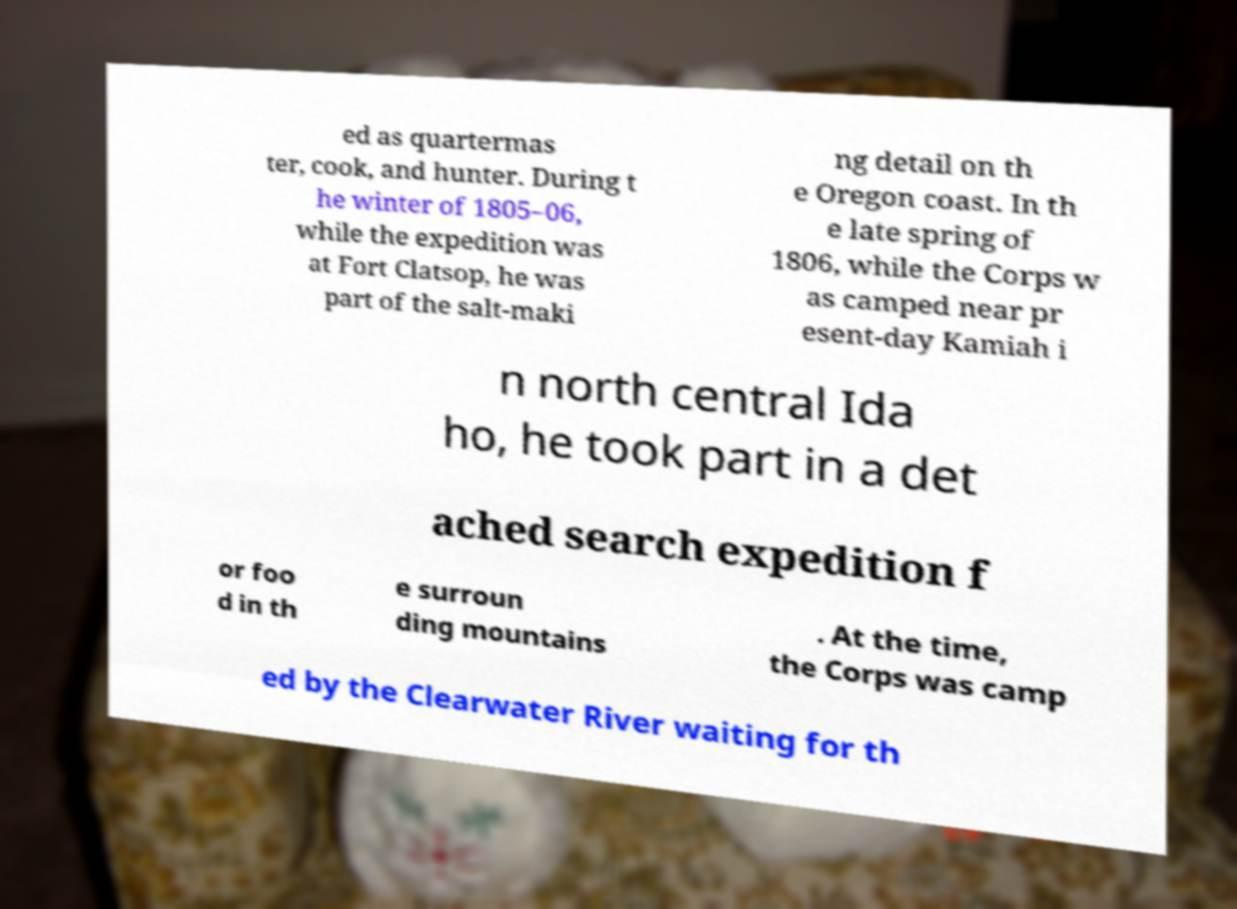Please identify and transcribe the text found in this image. ed as quartermas ter, cook, and hunter. During t he winter of 1805–06, while the expedition was at Fort Clatsop, he was part of the salt-maki ng detail on th e Oregon coast. In th e late spring of 1806, while the Corps w as camped near pr esent-day Kamiah i n north central Ida ho, he took part in a det ached search expedition f or foo d in th e surroun ding mountains . At the time, the Corps was camp ed by the Clearwater River waiting for th 